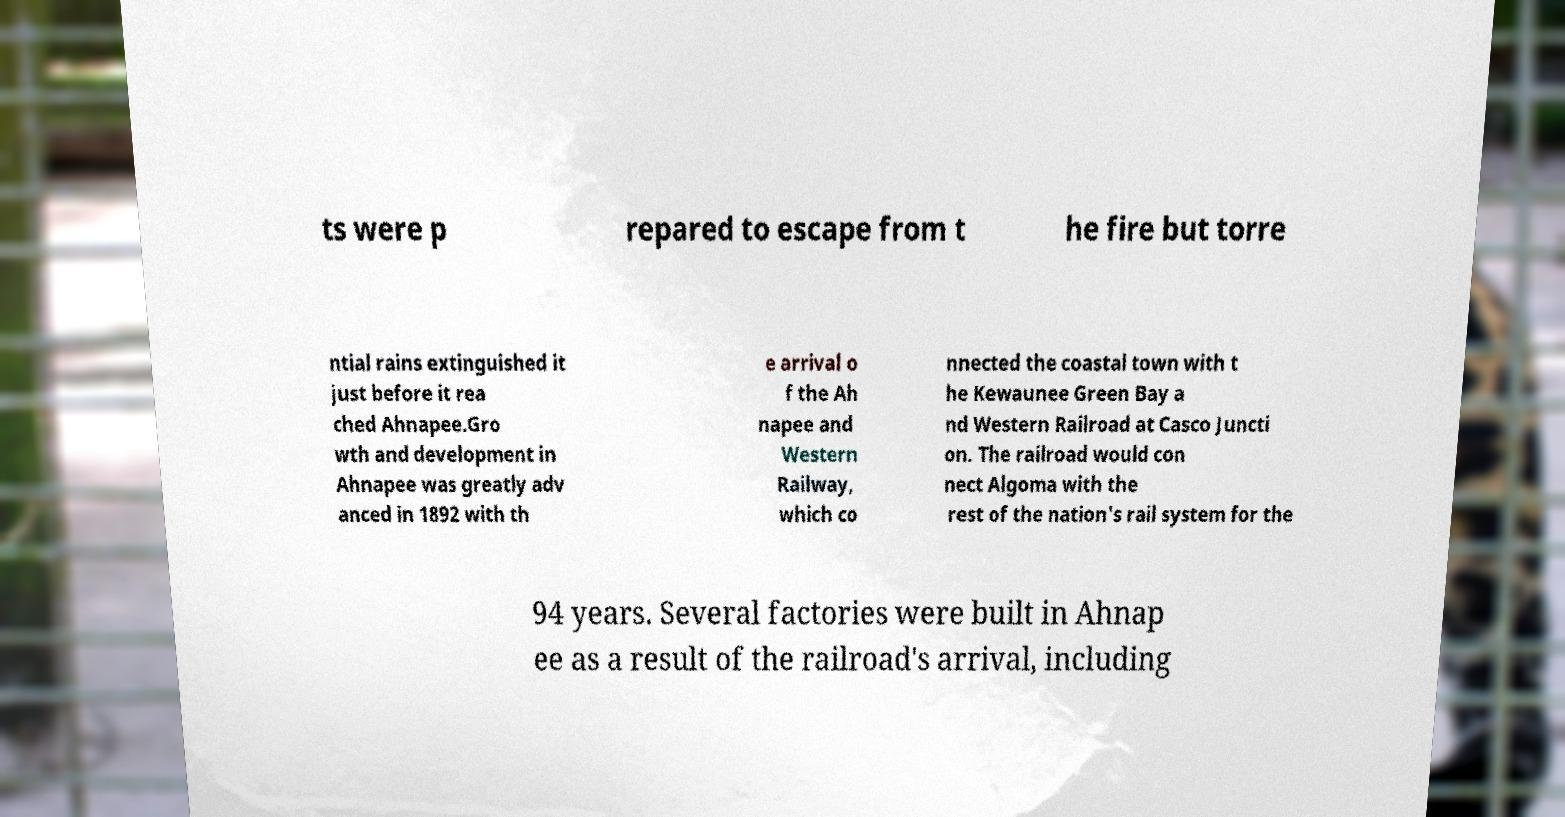Could you extract and type out the text from this image? ts were p repared to escape from t he fire but torre ntial rains extinguished it just before it rea ched Ahnapee.Gro wth and development in Ahnapee was greatly adv anced in 1892 with th e arrival o f the Ah napee and Western Railway, which co nnected the coastal town with t he Kewaunee Green Bay a nd Western Railroad at Casco Juncti on. The railroad would con nect Algoma with the rest of the nation's rail system for the 94 years. Several factories were built in Ahnap ee as a result of the railroad's arrival, including 